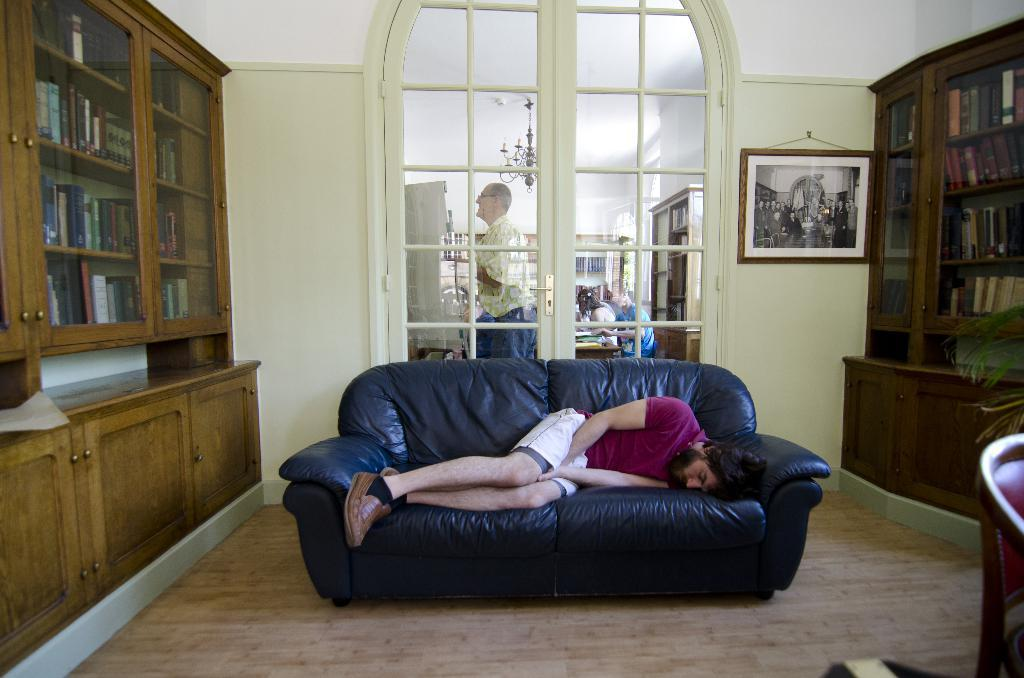What is the color of the wall in the image? The wall in the image is white. What can be seen hanging on the wall? There is a photo frame hanging on the wall in the image. What architectural feature is present in the image? There is a door in the image. What is happening behind the door? There are people behind the door in the image. What is used for hanging items in the image? There is a rack in the image. What is the man in the image doing? The man in the image is sleeping on a sofa. What type of quince is being used as a decoration in the image? There is no quince present in the image; it is a white wall with a photo frame, a door, a rack, and a man sleeping on a sofa. How does the chain of events unfold in the image? The image does not depict a sequence of events, so it is not possible to describe a chain of events. 